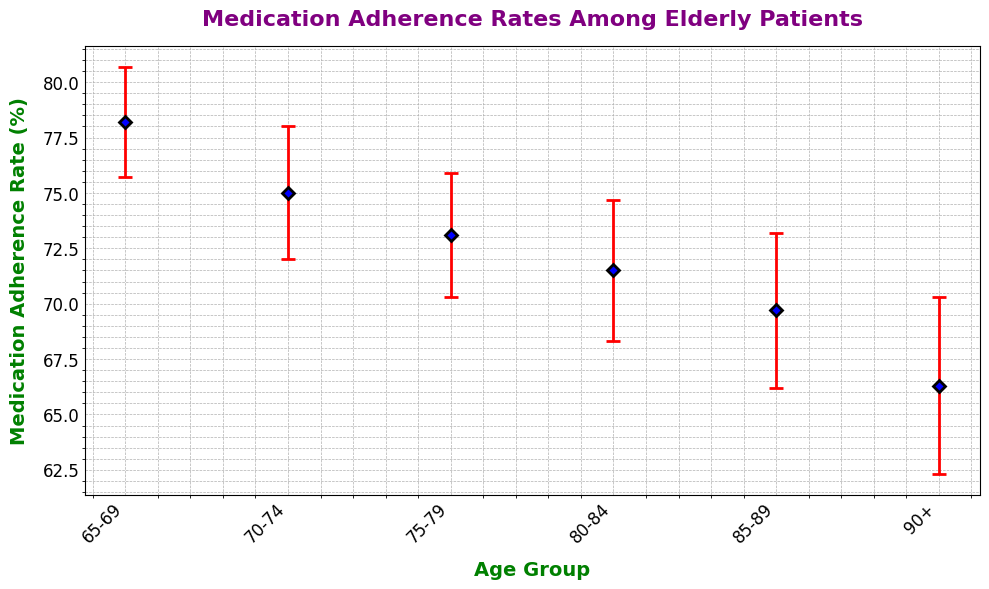What is the medication adherence rate for the age group 65-69? The medication adherence rate for the age group 65-69 can be directly read from the figure, which shows a value of 78.2%.
Answer: 78.2% Which age group has the lowest medication adherence rate? By comparing the adherence rates listed for all the age groups, the age group 90+ has the lowest adherence rate of 66.3%.
Answer: 90+ What is the difference in medication adherence rates between the age groups 65-69 and 90+? The adherence rate for the age group 65-69 is 78.2%, and for the age group 90+ it is 66.3%. The difference is calculated as 78.2% - 66.3% = 11.9%.
Answer: 11.9% Which age group has the highest error margin, and what is its value? By comparing the error margins for all age groups, the age group 90+ has the highest error margin of 4.0%.
Answer: 90+, 4.0% What is the average medication adherence rate for all age groups? To find the average, sum the adherence rates for all age groups [(78.2 + 75.0 + 73.1 + 71.5 + 69.7 + 66.3)/6] and divide by the number of age groups. The average is (433.8/6) = 72.3%.
Answer: 72.3% How does the medication adherence rate for the age group 75-79 compare to that of 80-84? The adherence rate for the age group 75-79 is 73.1%, while for the age group 80-84, it is 71.5%. The rate for 75-79 is higher by 1.6%.
Answer: 75-79 is higher by 1.6% What is the range of error margins across all age groups? The smallest error margin is 2.5% (65-69) and the largest is 4.0% (90+). The range is calculated as 4.0% - 2.5% = 1.5%.
Answer: 1.5% If the error margin were to be visualized on the plot, what color would represent it? The color used to depict error margins in the plot is red, as specified in the design of the plot through the 'ecolor' parameter.
Answer: Red Is the medication adherence rate for the age group 70-74 within the error margin of the rate for the age group 65-69? The adherence rate for 65-69 is 78.2% with an error margin of 2.5%, ranging from 75.7% to 80.7%. The adherence rate for 70-74 is 75.0%, which falls within this range.
Answer: Yes Which age groups have overlapping medication adherence rates within their respective error margins? Comparing the error margin ranges:  
- 65-69: 75.7% to 80.7%  
- 70-74: 72.0% to 78.0%  
- 75-79: 70.3% to 75.9%  
- 80-84: 68.3% to 74.7%  
- 85-89: 66.2% to 73.2%  
- 90+: 62.3% to 70.3%  
  
All age groups have overlapping adherence rates within their error margins.
Answer: All age groups 